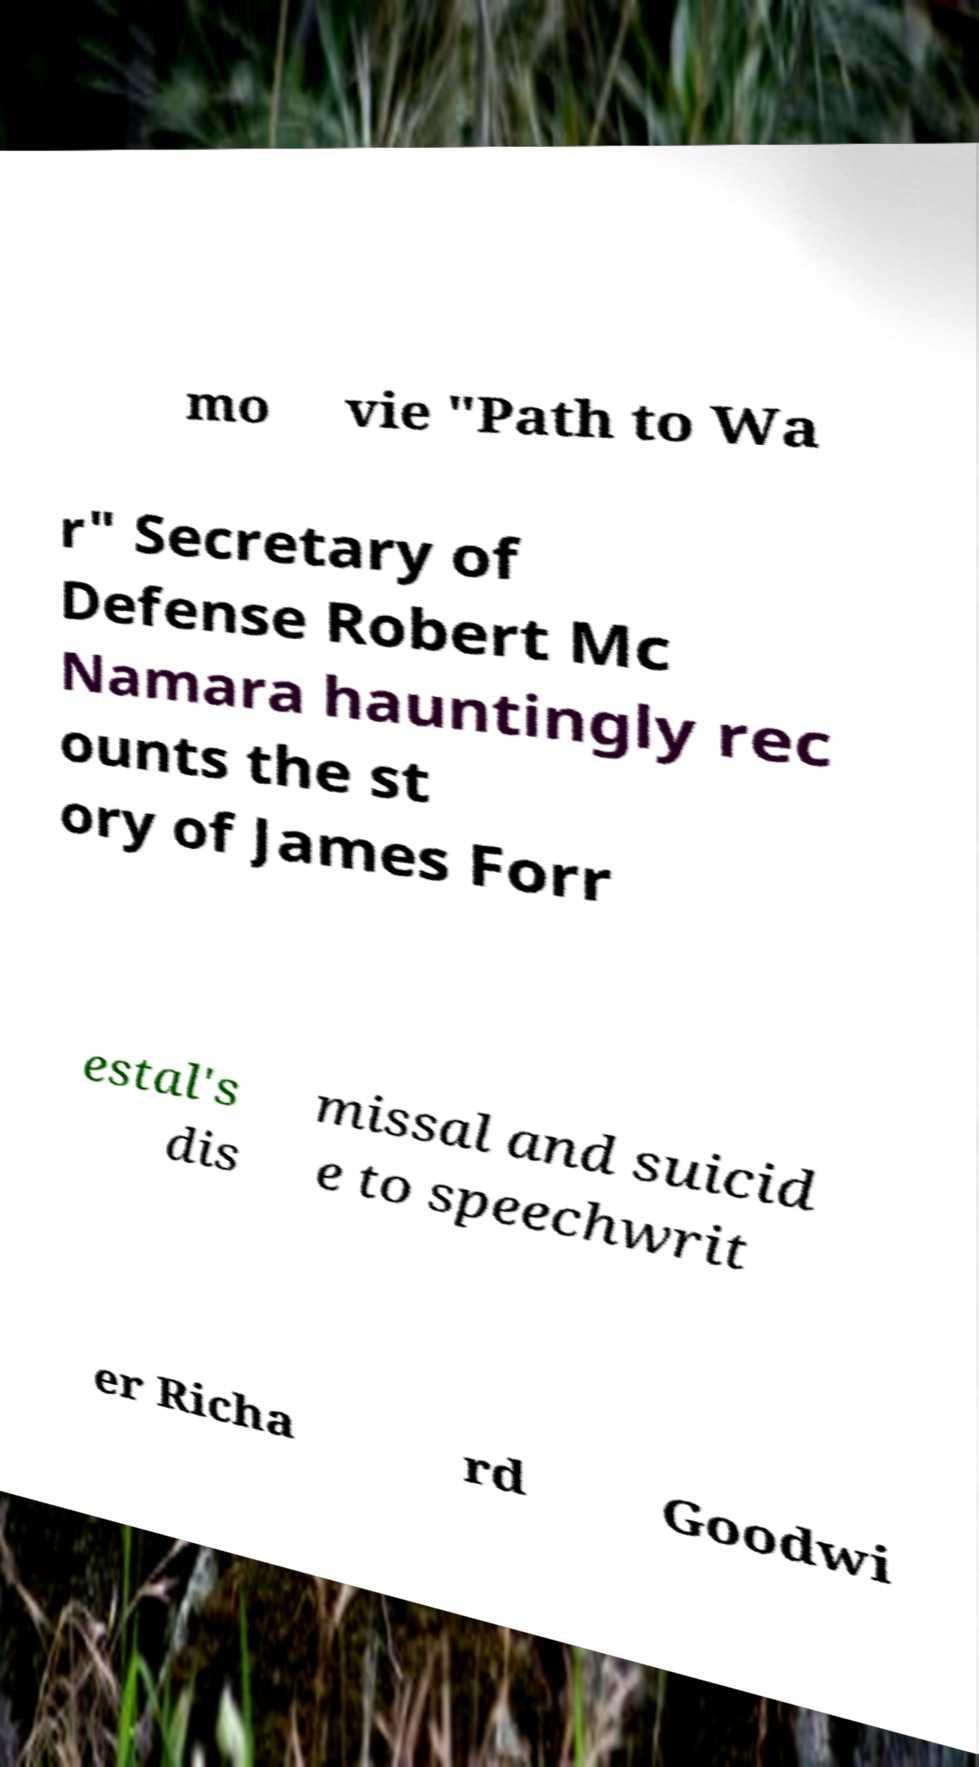Could you assist in decoding the text presented in this image and type it out clearly? mo vie "Path to Wa r" Secretary of Defense Robert Mc Namara hauntingly rec ounts the st ory of James Forr estal's dis missal and suicid e to speechwrit er Richa rd Goodwi 